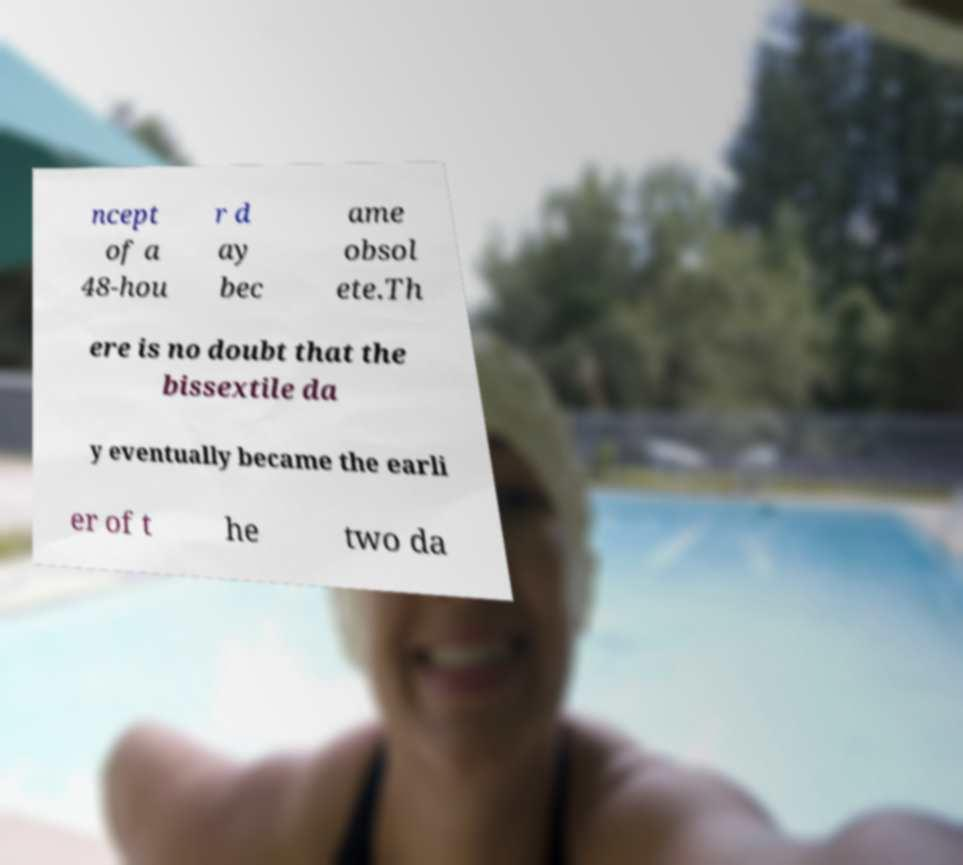Can you accurately transcribe the text from the provided image for me? ncept of a 48-hou r d ay bec ame obsol ete.Th ere is no doubt that the bissextile da y eventually became the earli er of t he two da 